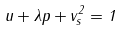<formula> <loc_0><loc_0><loc_500><loc_500>u + \lambda p + v _ { s } ^ { 2 } = 1</formula> 